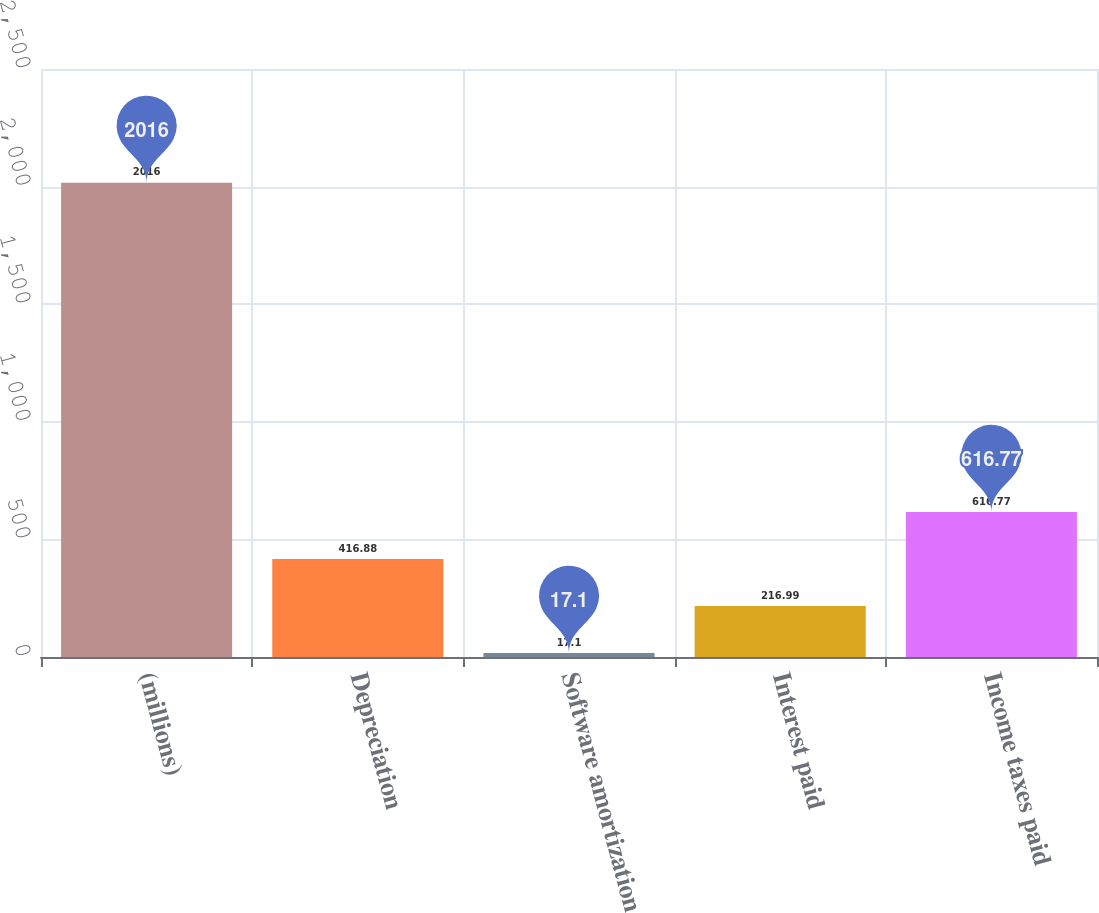<chart> <loc_0><loc_0><loc_500><loc_500><bar_chart><fcel>(millions)<fcel>Depreciation<fcel>Software amortization<fcel>Interest paid<fcel>Income taxes paid<nl><fcel>2016<fcel>416.88<fcel>17.1<fcel>216.99<fcel>616.77<nl></chart> 